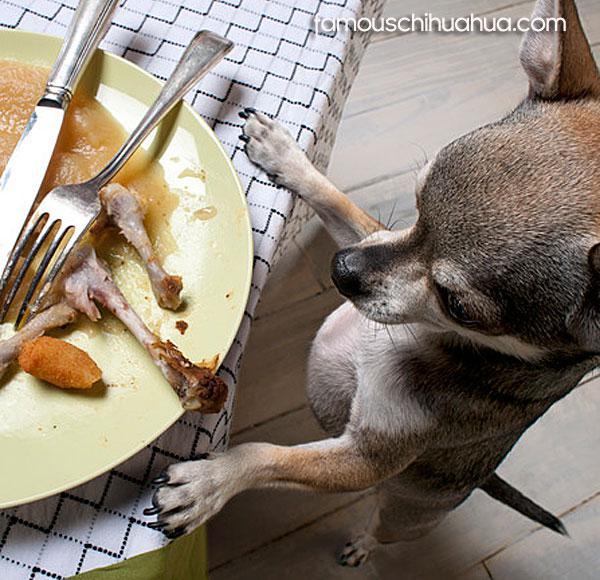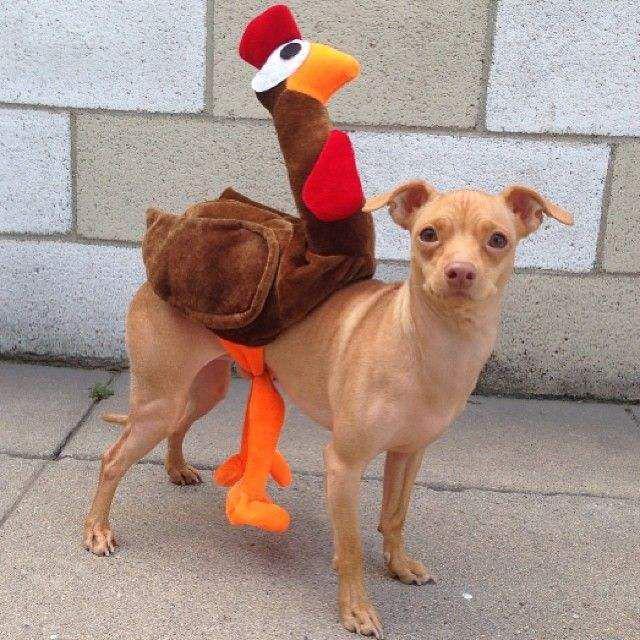The first image is the image on the left, the second image is the image on the right. Analyze the images presented: Is the assertion "There is a chihuahua that is wearing a costume in each image." valid? Answer yes or no. No. The first image is the image on the left, the second image is the image on the right. Examine the images to the left and right. Is the description "The dog in the image on the left is sitting before a plate of human food." accurate? Answer yes or no. Yes. 